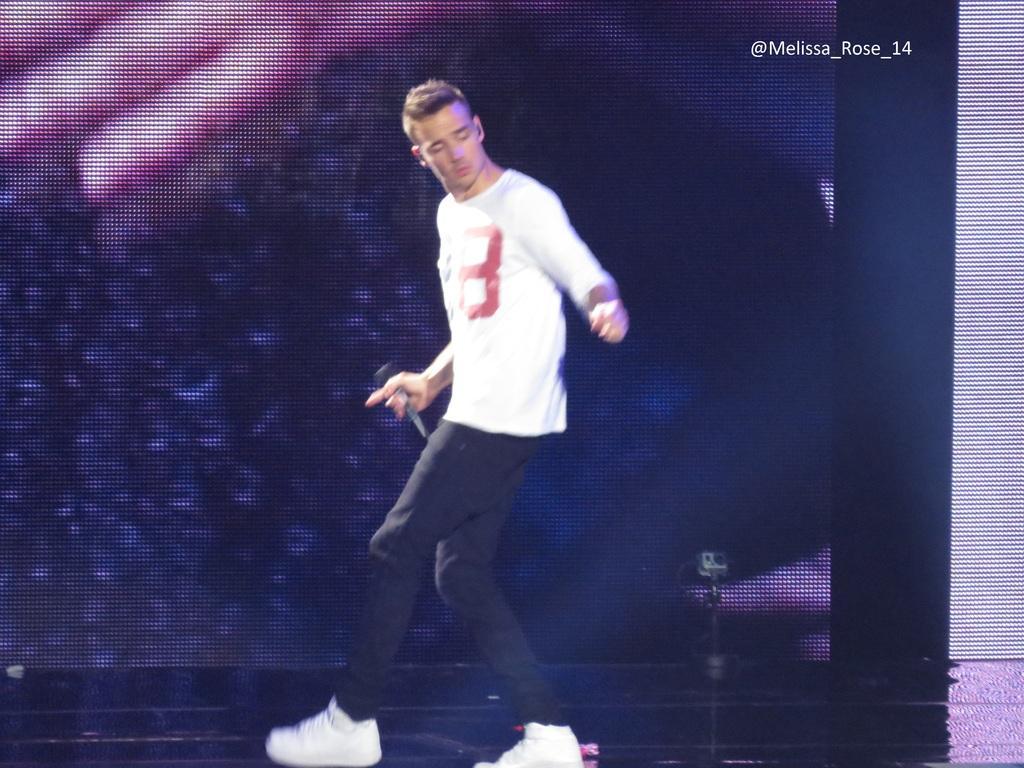Please provide a concise description of this image. In this image I can see a person is holding a mic and wearing black and white color dress. Back I can see a colorful screen. 